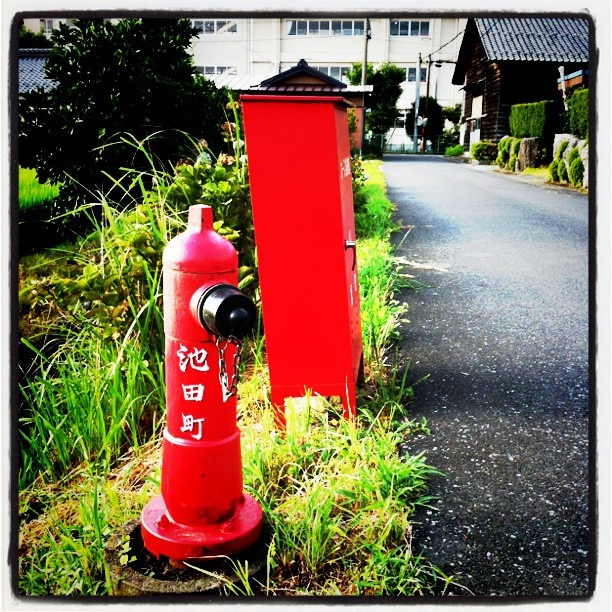Describe the objects in this image and their specific colors. I can see a fire hydrant in white, red, and black tones in this image. 